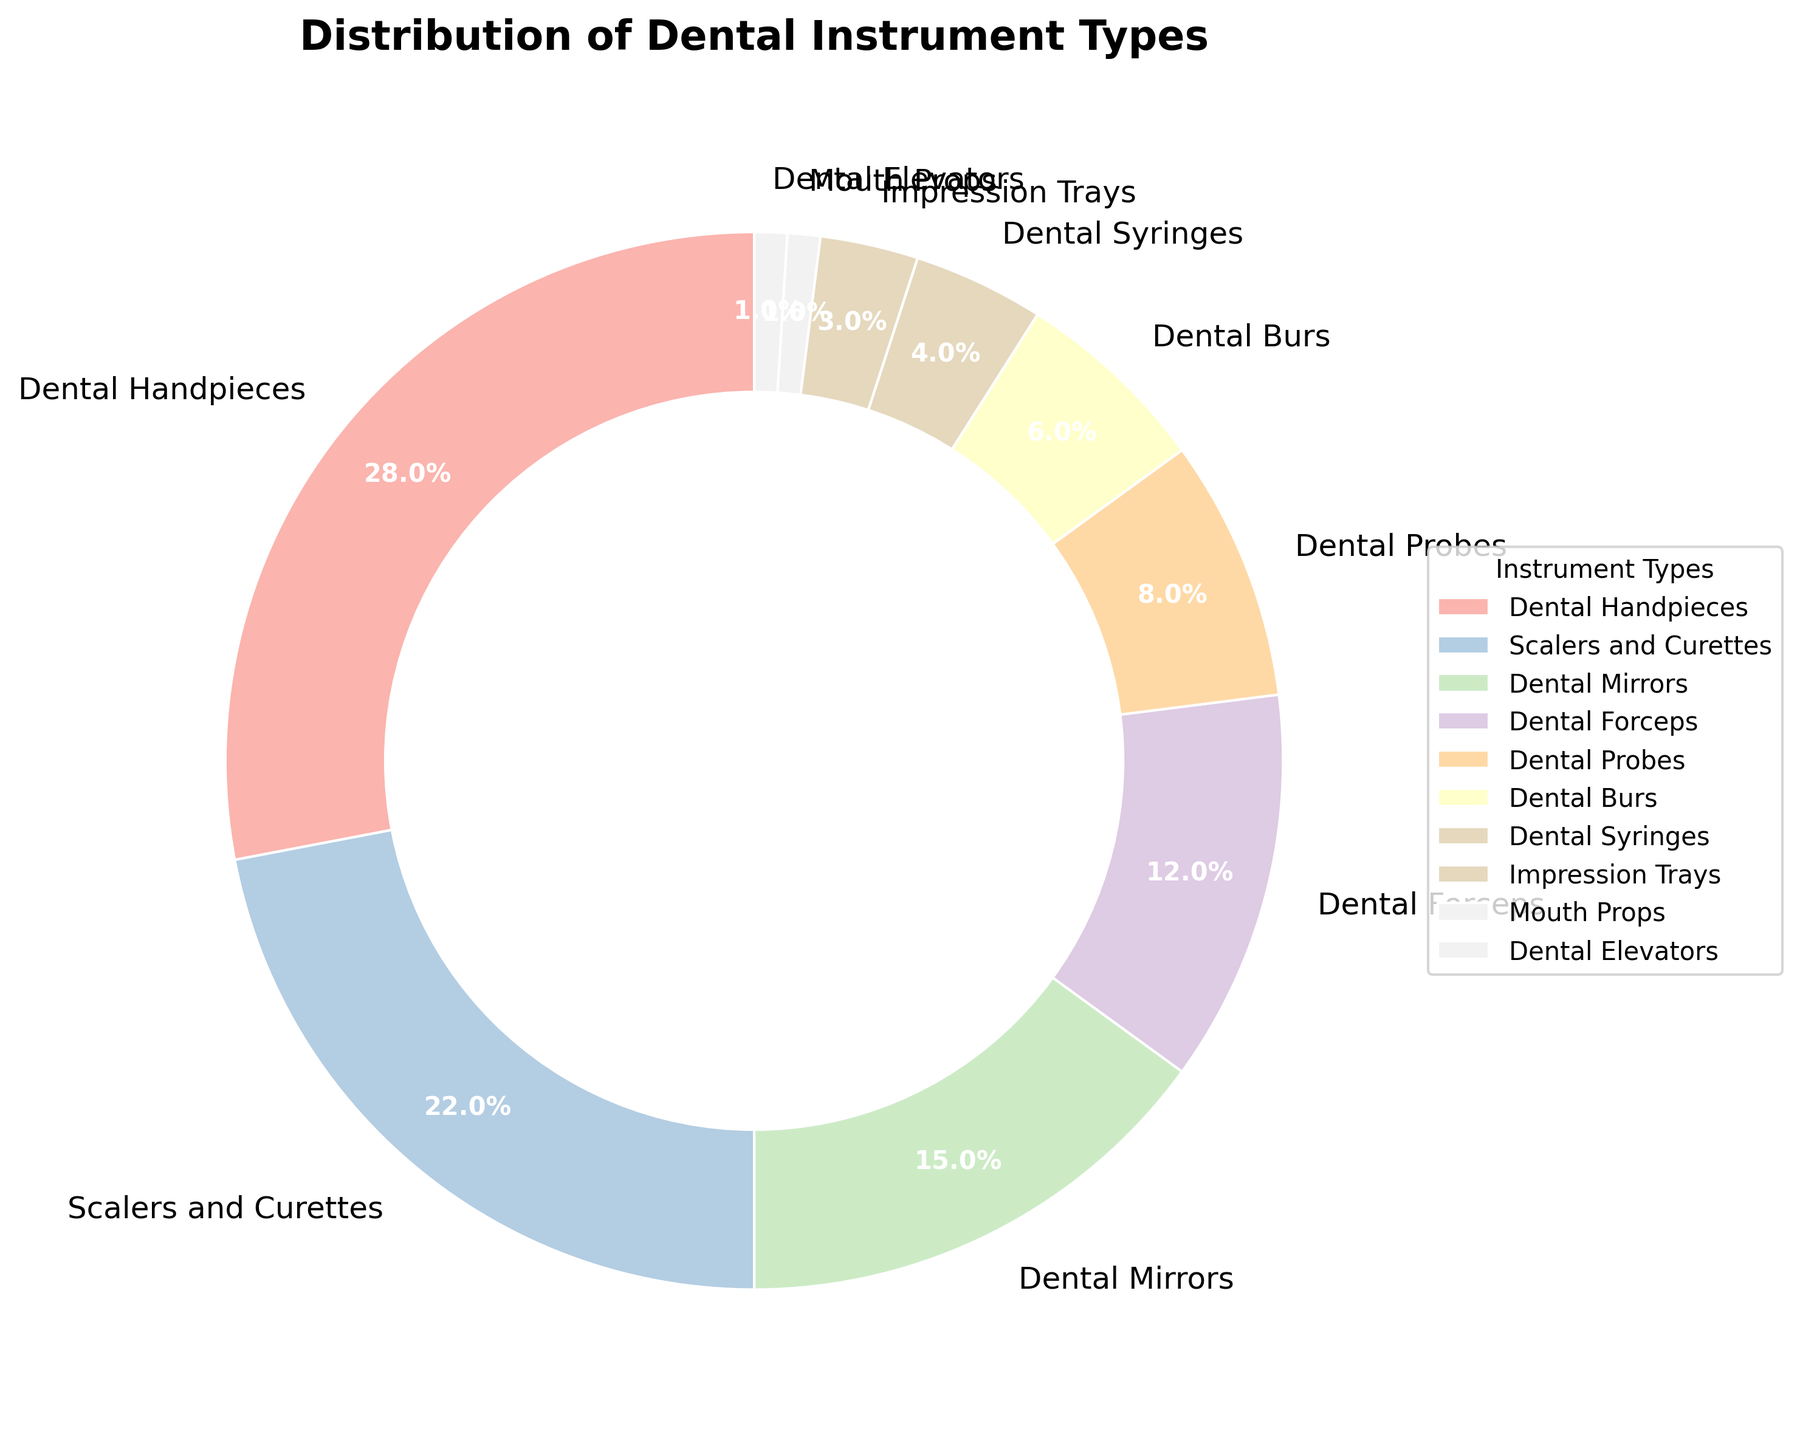What is the second most produced dental instrument type? The pie chart shows various dental instrument types and their production percentages. The second-largest slice corresponds to Scalers and Curettes at 22%.
Answer: Scalers and Curettes What is the combined percentage for Dental Probes and Dental Burs? Based on the pie chart, Dental Probes account for 8% and Dental Burs for 6%. Adding these two percentages gives 8% + 6% = 14%.
Answer: 14% Which dental instrument has the smallest production percentage? Observing the pie chart, the smallest slice is for Mouth Props and Dental Elevators, each accounting for just 1%.
Answer: Mouth Props and Dental Elevators Are Dental Handpieces produced in a higher percentage than Dental Mirrors and Dental Probes combined? Dental Handpieces are produced at 28%. Adding Dental Mirrors (15%) and Dental Probes (8%) gives 23%. Since 28% is greater than 23%, yes, Dental Handpieces are produced in a higher percentage.
Answer: Yes Which segment in the pie chart appears in lightest colors and what are their percentages? The lightest colors in the pastel palette are generally associated with the smallest slices. The smallest segments are Mouth Props and Dental Elevators, each at 1%.
Answer: Mouth Props and Dental Elevators, 1% Do Dental Forceps and Dental Syringes together account for more than Dental Mirrors alone? Dental Forceps are 12% and Dental Syringes are 4%, totaling 12% + 4% = 16%. Dental Mirrors are 15%. Since 16% > 15%, they account for more.
Answer: Yes What instrument type follows Dental Handpieces in production percentage? The largest slice is for Dental Handpieces (28%). The next largest slice is for Scalers and Curettes with 22%.
Answer: Scalers and Curettes How much more is the production percentage of Dental Handpieces compared to Impression Trays? Dental Handpieces are produced at 28%, and Impression Trays at 3%. Subtracting these percentages gives 28% - 3% = 25%.
Answer: 25% Which three instrument types have the lowest production percentages? The pie chart shows that Mouth Props (1%), Dental Elevators (1%), and Impression Trays (3%) have the lowest production percentages.
Answer: Mouth Props, Dental Elevators, Impression Trays 